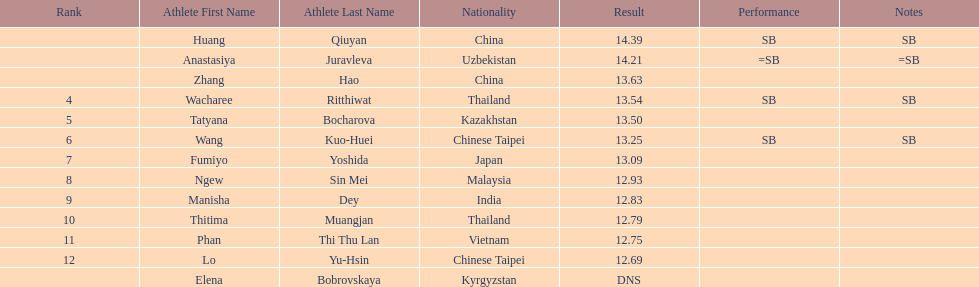How long was manisha dey's jump? 12.83. 